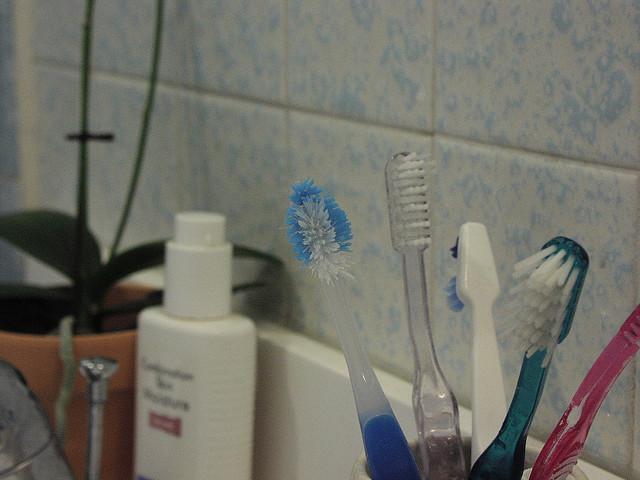How many toothbrushes are in this picture?
Write a very short answer. 5. How many toothbrushes are in the cup?
Be succinct. 5. How many plastic bottles are there in the picture?
Keep it brief. 1. How many toothbrushes?
Write a very short answer. 5. Do some of the brushes need to be replaced?
Answer briefly. Yes. What kind of toothpaste is in the photo?
Concise answer only. None. What is in the bottle?
Write a very short answer. Lotion. Is there a plant present?
Keep it brief. Yes. 